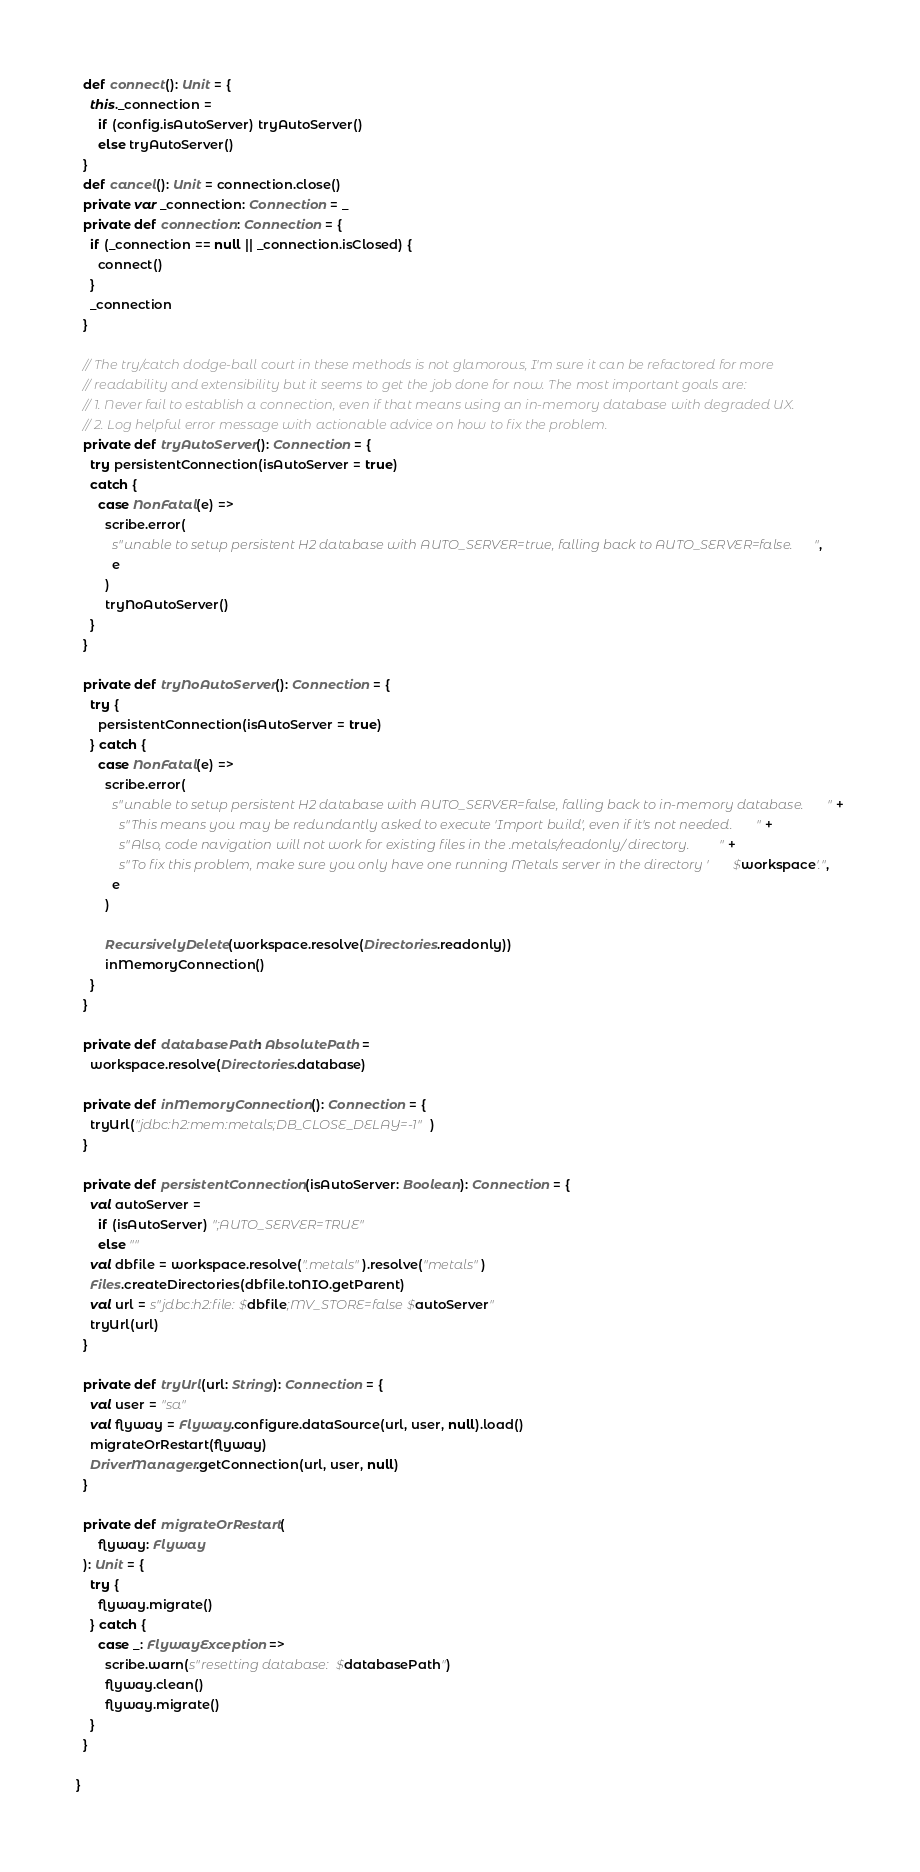<code> <loc_0><loc_0><loc_500><loc_500><_Scala_>  def connect(): Unit = {
    this._connection =
      if (config.isAutoServer) tryAutoServer()
      else tryAutoServer()
  }
  def cancel(): Unit = connection.close()
  private var _connection: Connection = _
  private def connection: Connection = {
    if (_connection == null || _connection.isClosed) {
      connect()
    }
    _connection
  }

  // The try/catch dodge-ball court in these methods is not glamorous, I'm sure it can be refactored for more
  // readability and extensibility but it seems to get the job done for now. The most important goals are:
  // 1. Never fail to establish a connection, even if that means using an in-memory database with degraded UX.
  // 2. Log helpful error message with actionable advice on how to fix the problem.
  private def tryAutoServer(): Connection = {
    try persistentConnection(isAutoServer = true)
    catch {
      case NonFatal(e) =>
        scribe.error(
          s"unable to setup persistent H2 database with AUTO_SERVER=true, falling back to AUTO_SERVER=false.",
          e
        )
        tryNoAutoServer()
    }
  }

  private def tryNoAutoServer(): Connection = {
    try {
      persistentConnection(isAutoServer = true)
    } catch {
      case NonFatal(e) =>
        scribe.error(
          s"unable to setup persistent H2 database with AUTO_SERVER=false, falling back to in-memory database. " +
            s"This means you may be redundantly asked to execute 'Import build', even if it's not needed. " +
            s"Also, code navigation will not work for existing files in the .metals/readonly/ directory. " +
            s"To fix this problem, make sure you only have one running Metals server in the directory '$workspace'.",
          e
        )

        RecursivelyDelete(workspace.resolve(Directories.readonly))
        inMemoryConnection()
    }
  }

  private def databasePath: AbsolutePath =
    workspace.resolve(Directories.database)

  private def inMemoryConnection(): Connection = {
    tryUrl("jdbc:h2:mem:metals;DB_CLOSE_DELAY=-1")
  }

  private def persistentConnection(isAutoServer: Boolean): Connection = {
    val autoServer =
      if (isAutoServer) ";AUTO_SERVER=TRUE"
      else ""
    val dbfile = workspace.resolve(".metals").resolve("metals")
    Files.createDirectories(dbfile.toNIO.getParent)
    val url = s"jdbc:h2:file:$dbfile;MV_STORE=false$autoServer"
    tryUrl(url)
  }

  private def tryUrl(url: String): Connection = {
    val user = "sa"
    val flyway = Flyway.configure.dataSource(url, user, null).load()
    migrateOrRestart(flyway)
    DriverManager.getConnection(url, user, null)
  }

  private def migrateOrRestart(
      flyway: Flyway
  ): Unit = {
    try {
      flyway.migrate()
    } catch {
      case _: FlywayException =>
        scribe.warn(s"resetting database: $databasePath")
        flyway.clean()
        flyway.migrate()
    }
  }

}
</code> 